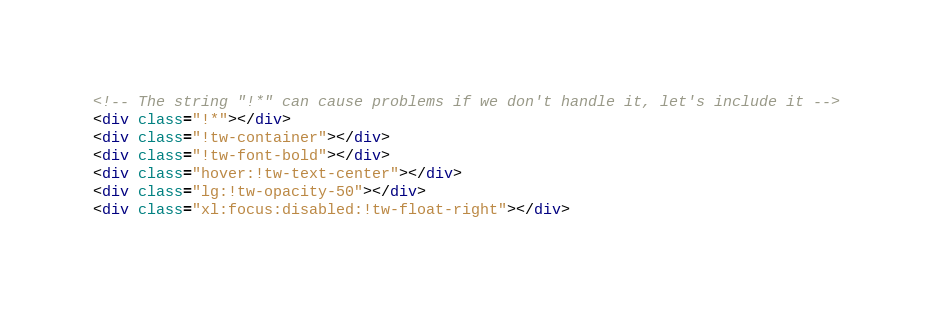<code> <loc_0><loc_0><loc_500><loc_500><_HTML_><!-- The string "!*" can cause problems if we don't handle it, let's include it -->
<div class="!*"></div>
<div class="!tw-container"></div>
<div class="!tw-font-bold"></div>
<div class="hover:!tw-text-center"></div>
<div class="lg:!tw-opacity-50"></div>
<div class="xl:focus:disabled:!tw-float-right"></div>
</code> 